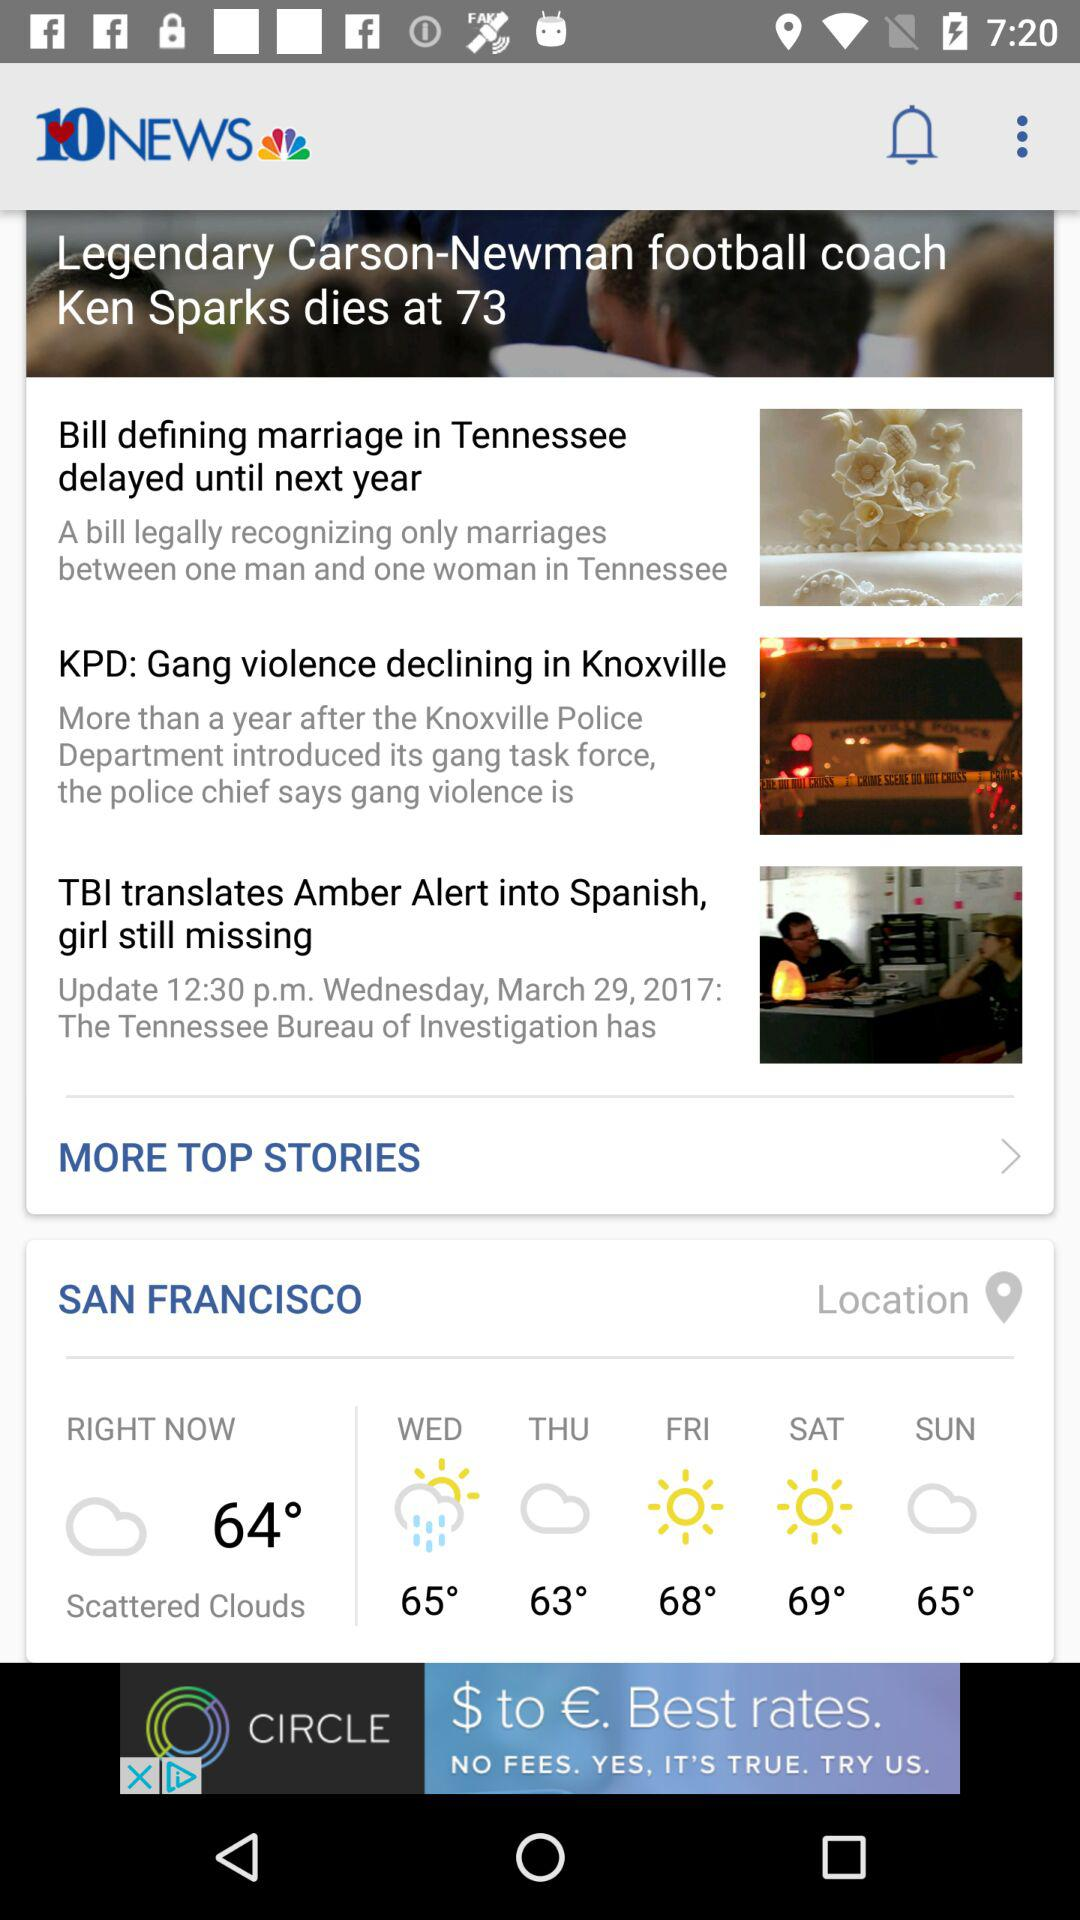What is the selected location? The selected location is San Francisco. 